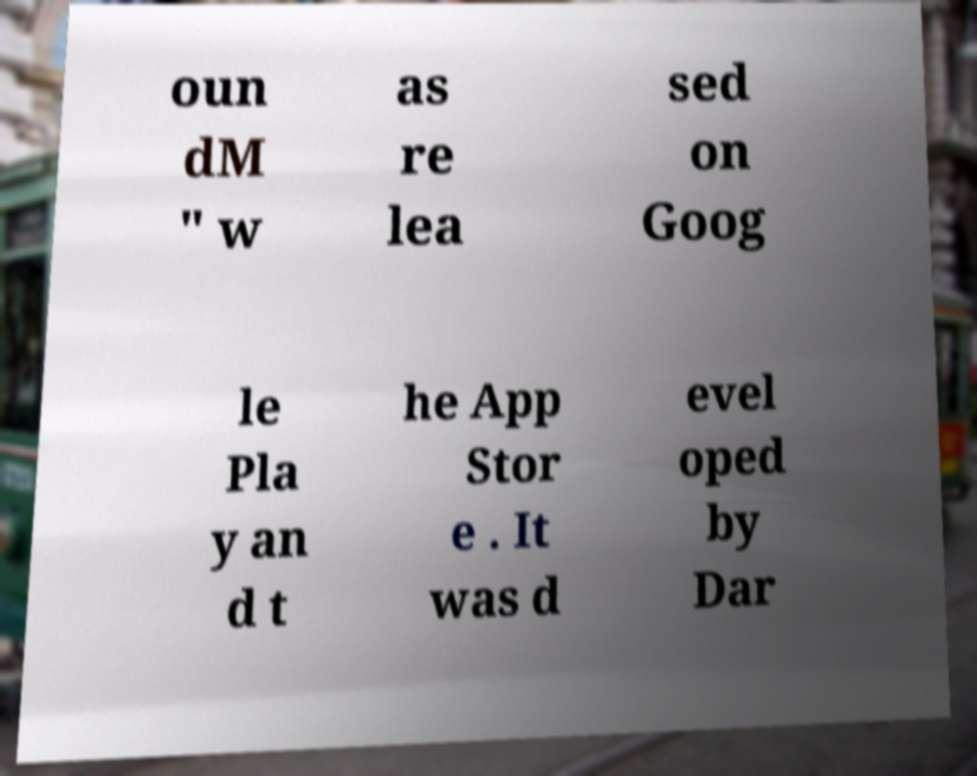Please read and relay the text visible in this image. What does it say? oun dM " w as re lea sed on Goog le Pla y an d t he App Stor e . It was d evel oped by Dar 